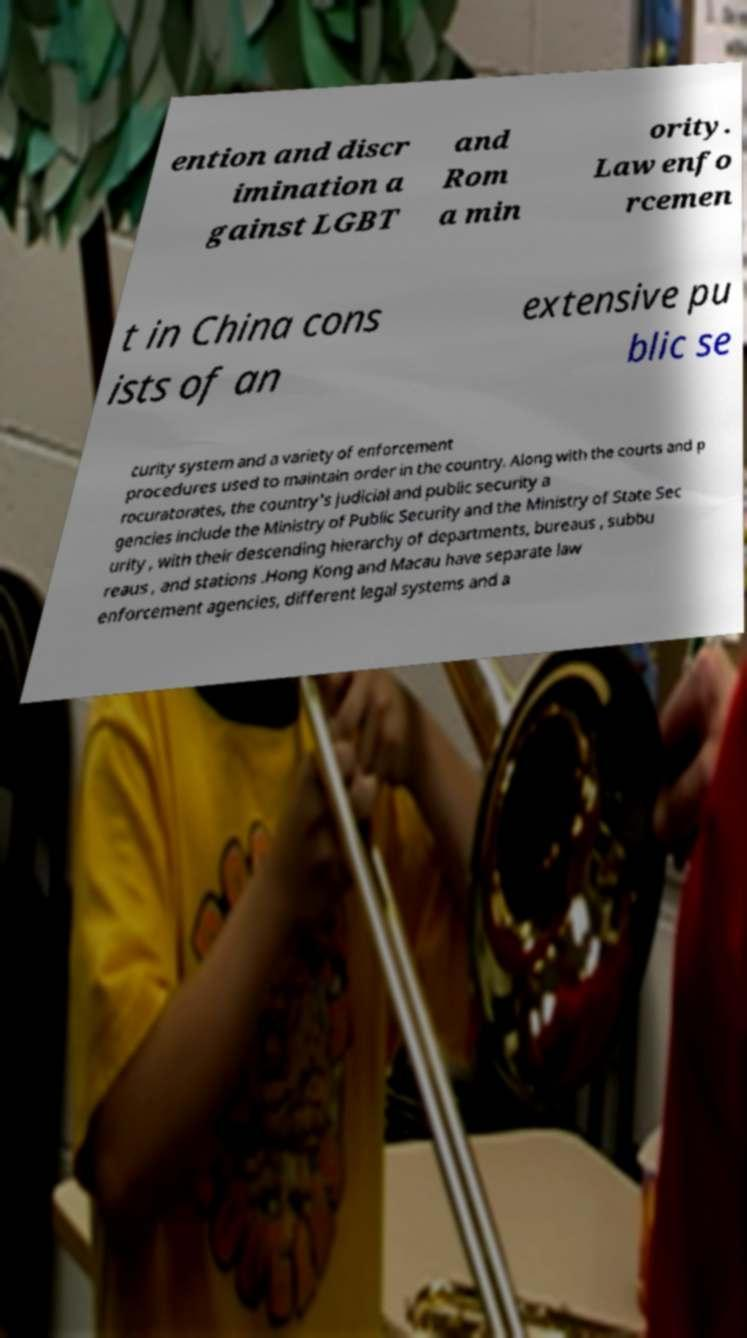Can you accurately transcribe the text from the provided image for me? ention and discr imination a gainst LGBT and Rom a min ority. Law enfo rcemen t in China cons ists of an extensive pu blic se curity system and a variety of enforcement procedures used to maintain order in the country. Along with the courts and p rocuratorates, the country's judicial and public security a gencies include the Ministry of Public Security and the Ministry of State Sec urity , with their descending hierarchy of departments, bureaus , subbu reaus , and stations .Hong Kong and Macau have separate law enforcement agencies, different legal systems and a 